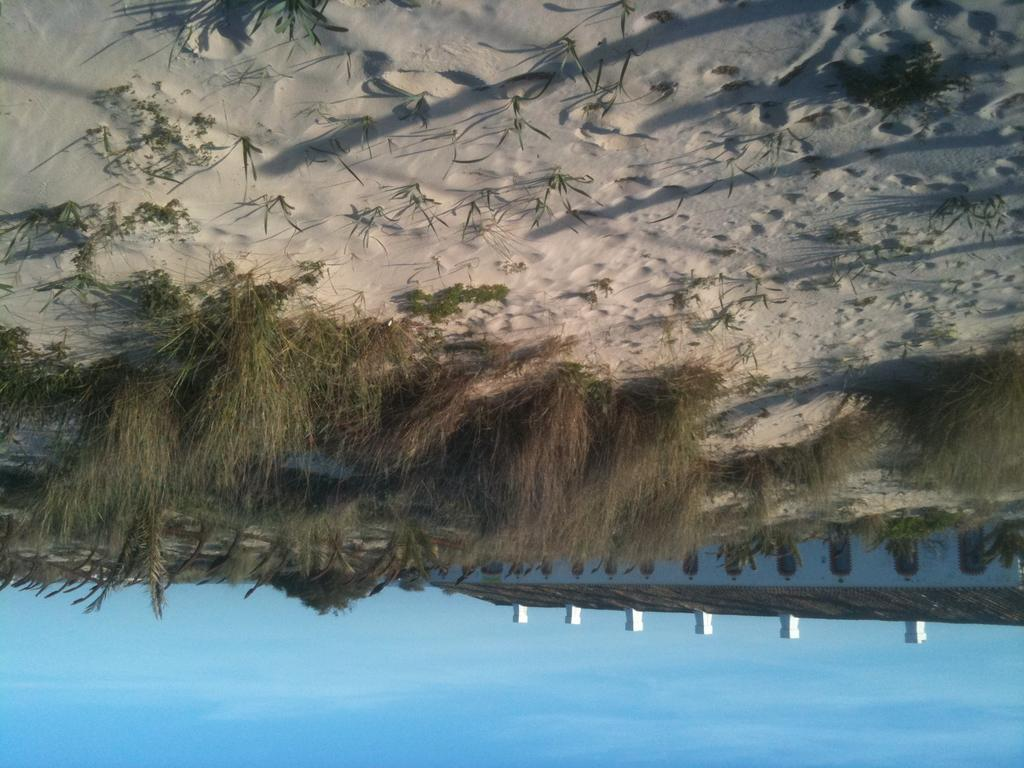What color is the sky in the image? The sky is blue in the image. What type of vegetation can be seen in the background of the image? The background of the image includes grass, which is green. What type of terrain is visible in the image? There is sand visible in the image. What type of range can be seen in the image? There is no range present in the image; it features a blue sky, green grass, and sand. What songs are being sung by the people in the image? There are no people or songs present in the image. 